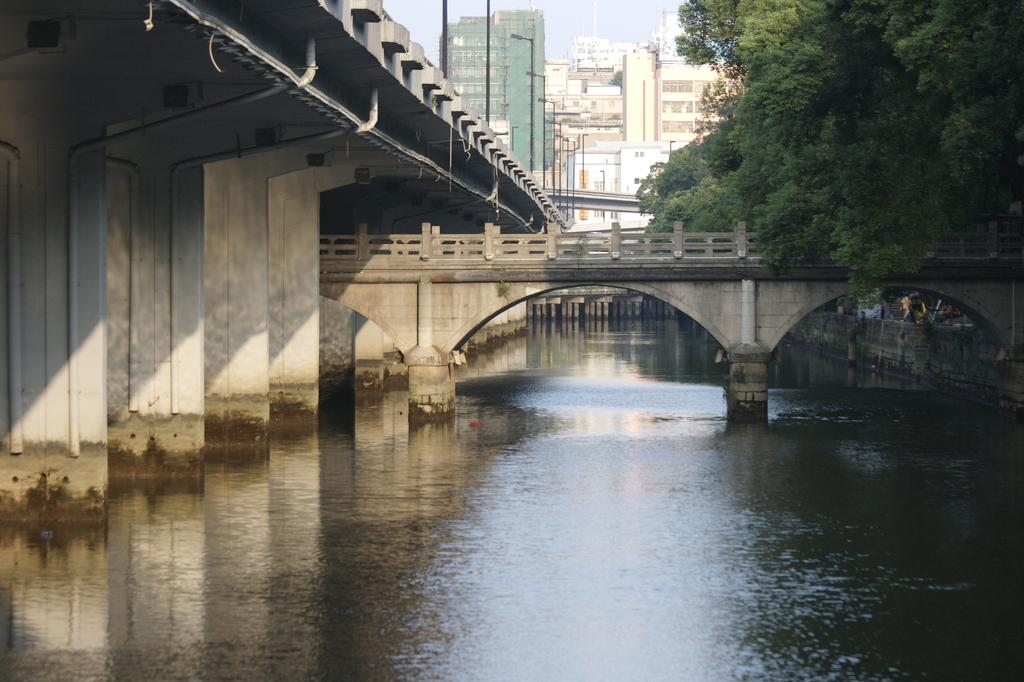What is the main structure in the center of the image? There is a bridge in the center of the image. What can be seen at the bottom of the image? There is water at the bottom of the image. What type of natural elements are visible in the background of the image? There are trees in the background of the image. What type of artificial elements are visible in the background of the image? Street lights and buildings are present in the background of the image. What is visible in the sky in the background of the image? The sky is visible in the background of the image. What is the weight of the industry in the image? There is no industry present in the image, so it is not possible to determine its weight. 